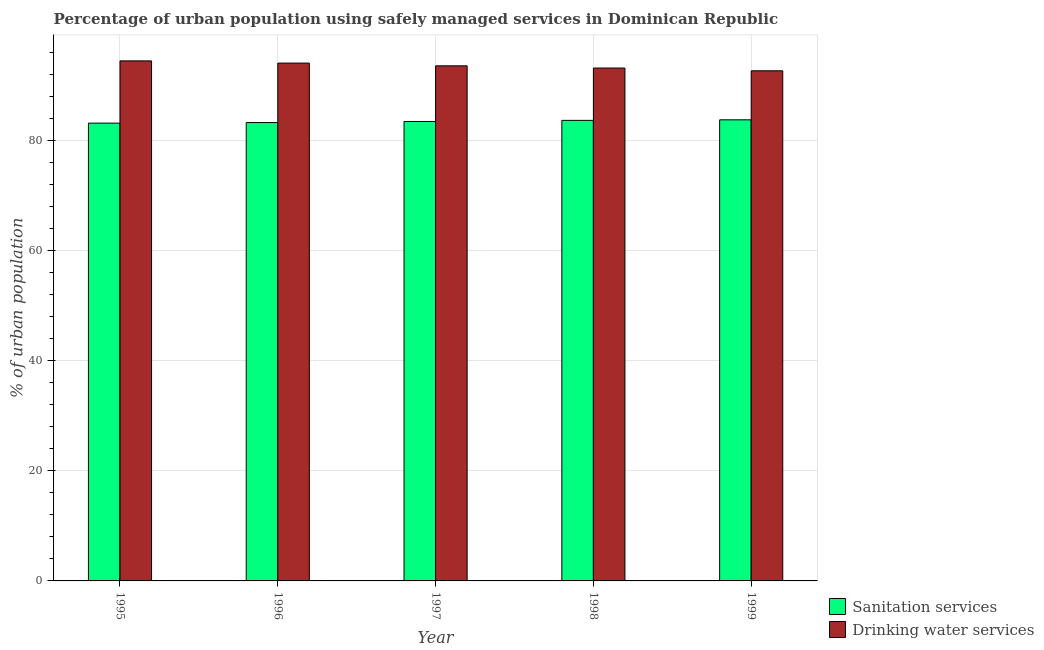Are the number of bars on each tick of the X-axis equal?
Provide a short and direct response. Yes. How many bars are there on the 4th tick from the left?
Offer a terse response. 2. In how many cases, is the number of bars for a given year not equal to the number of legend labels?
Your response must be concise. 0. What is the percentage of urban population who used drinking water services in 1996?
Your answer should be compact. 94. Across all years, what is the maximum percentage of urban population who used drinking water services?
Make the answer very short. 94.4. Across all years, what is the minimum percentage of urban population who used drinking water services?
Offer a very short reply. 92.6. In which year was the percentage of urban population who used drinking water services maximum?
Your response must be concise. 1995. In which year was the percentage of urban population who used sanitation services minimum?
Make the answer very short. 1995. What is the total percentage of urban population who used sanitation services in the graph?
Your response must be concise. 417. What is the difference between the percentage of urban population who used drinking water services in 1996 and that in 1999?
Make the answer very short. 1.4. What is the difference between the percentage of urban population who used sanitation services in 1999 and the percentage of urban population who used drinking water services in 1998?
Your answer should be compact. 0.1. What is the average percentage of urban population who used drinking water services per year?
Your answer should be compact. 93.52. What is the ratio of the percentage of urban population who used drinking water services in 1996 to that in 1999?
Provide a succinct answer. 1.02. Is the difference between the percentage of urban population who used drinking water services in 1997 and 1998 greater than the difference between the percentage of urban population who used sanitation services in 1997 and 1998?
Keep it short and to the point. No. What is the difference between the highest and the second highest percentage of urban population who used sanitation services?
Provide a succinct answer. 0.1. What is the difference between the highest and the lowest percentage of urban population who used drinking water services?
Provide a succinct answer. 1.8. Is the sum of the percentage of urban population who used drinking water services in 1995 and 1998 greater than the maximum percentage of urban population who used sanitation services across all years?
Make the answer very short. Yes. What does the 2nd bar from the left in 1995 represents?
Provide a succinct answer. Drinking water services. What does the 1st bar from the right in 1998 represents?
Offer a terse response. Drinking water services. How many bars are there?
Offer a terse response. 10. Are all the bars in the graph horizontal?
Give a very brief answer. No. What is the difference between two consecutive major ticks on the Y-axis?
Provide a short and direct response. 20. Are the values on the major ticks of Y-axis written in scientific E-notation?
Offer a very short reply. No. What is the title of the graph?
Keep it short and to the point. Percentage of urban population using safely managed services in Dominican Republic. What is the label or title of the X-axis?
Ensure brevity in your answer.  Year. What is the label or title of the Y-axis?
Offer a terse response. % of urban population. What is the % of urban population of Sanitation services in 1995?
Ensure brevity in your answer.  83.1. What is the % of urban population in Drinking water services in 1995?
Make the answer very short. 94.4. What is the % of urban population of Sanitation services in 1996?
Your response must be concise. 83.2. What is the % of urban population of Drinking water services in 1996?
Offer a terse response. 94. What is the % of urban population in Sanitation services in 1997?
Ensure brevity in your answer.  83.4. What is the % of urban population in Drinking water services in 1997?
Ensure brevity in your answer.  93.5. What is the % of urban population of Sanitation services in 1998?
Your answer should be compact. 83.6. What is the % of urban population in Drinking water services in 1998?
Provide a short and direct response. 93.1. What is the % of urban population of Sanitation services in 1999?
Provide a short and direct response. 83.7. What is the % of urban population in Drinking water services in 1999?
Ensure brevity in your answer.  92.6. Across all years, what is the maximum % of urban population in Sanitation services?
Ensure brevity in your answer.  83.7. Across all years, what is the maximum % of urban population of Drinking water services?
Keep it short and to the point. 94.4. Across all years, what is the minimum % of urban population of Sanitation services?
Keep it short and to the point. 83.1. Across all years, what is the minimum % of urban population in Drinking water services?
Make the answer very short. 92.6. What is the total % of urban population in Sanitation services in the graph?
Your response must be concise. 417. What is the total % of urban population in Drinking water services in the graph?
Make the answer very short. 467.6. What is the difference between the % of urban population of Sanitation services in 1995 and that in 1996?
Keep it short and to the point. -0.1. What is the difference between the % of urban population in Drinking water services in 1995 and that in 1997?
Provide a short and direct response. 0.9. What is the difference between the % of urban population in Drinking water services in 1995 and that in 1998?
Provide a succinct answer. 1.3. What is the difference between the % of urban population of Sanitation services in 1995 and that in 1999?
Offer a terse response. -0.6. What is the difference between the % of urban population in Sanitation services in 1996 and that in 1997?
Your response must be concise. -0.2. What is the difference between the % of urban population in Sanitation services in 1996 and that in 1998?
Your response must be concise. -0.4. What is the difference between the % of urban population in Drinking water services in 1996 and that in 1998?
Give a very brief answer. 0.9. What is the difference between the % of urban population of Sanitation services in 1998 and that in 1999?
Offer a terse response. -0.1. What is the difference between the % of urban population in Drinking water services in 1998 and that in 1999?
Offer a terse response. 0.5. What is the difference between the % of urban population of Sanitation services in 1995 and the % of urban population of Drinking water services in 1998?
Your answer should be compact. -10. What is the difference between the % of urban population in Sanitation services in 1996 and the % of urban population in Drinking water services in 1999?
Your response must be concise. -9.4. What is the average % of urban population in Sanitation services per year?
Provide a short and direct response. 83.4. What is the average % of urban population of Drinking water services per year?
Provide a short and direct response. 93.52. In the year 1995, what is the difference between the % of urban population in Sanitation services and % of urban population in Drinking water services?
Your answer should be compact. -11.3. What is the ratio of the % of urban population in Sanitation services in 1995 to that in 1996?
Offer a very short reply. 1. What is the ratio of the % of urban population of Drinking water services in 1995 to that in 1996?
Your answer should be very brief. 1. What is the ratio of the % of urban population of Sanitation services in 1995 to that in 1997?
Offer a very short reply. 1. What is the ratio of the % of urban population of Drinking water services in 1995 to that in 1997?
Give a very brief answer. 1.01. What is the ratio of the % of urban population in Drinking water services in 1995 to that in 1998?
Your response must be concise. 1.01. What is the ratio of the % of urban population of Drinking water services in 1995 to that in 1999?
Your response must be concise. 1.02. What is the ratio of the % of urban population in Sanitation services in 1996 to that in 1997?
Provide a short and direct response. 1. What is the ratio of the % of urban population of Drinking water services in 1996 to that in 1997?
Keep it short and to the point. 1.01. What is the ratio of the % of urban population in Drinking water services in 1996 to that in 1998?
Ensure brevity in your answer.  1.01. What is the ratio of the % of urban population of Drinking water services in 1996 to that in 1999?
Your answer should be very brief. 1.02. What is the ratio of the % of urban population in Sanitation services in 1997 to that in 1998?
Provide a short and direct response. 1. What is the ratio of the % of urban population of Drinking water services in 1997 to that in 1999?
Provide a short and direct response. 1.01. What is the ratio of the % of urban population of Sanitation services in 1998 to that in 1999?
Your answer should be compact. 1. What is the ratio of the % of urban population of Drinking water services in 1998 to that in 1999?
Ensure brevity in your answer.  1.01. What is the difference between the highest and the second highest % of urban population in Drinking water services?
Keep it short and to the point. 0.4. What is the difference between the highest and the lowest % of urban population in Sanitation services?
Provide a short and direct response. 0.6. What is the difference between the highest and the lowest % of urban population in Drinking water services?
Your answer should be very brief. 1.8. 